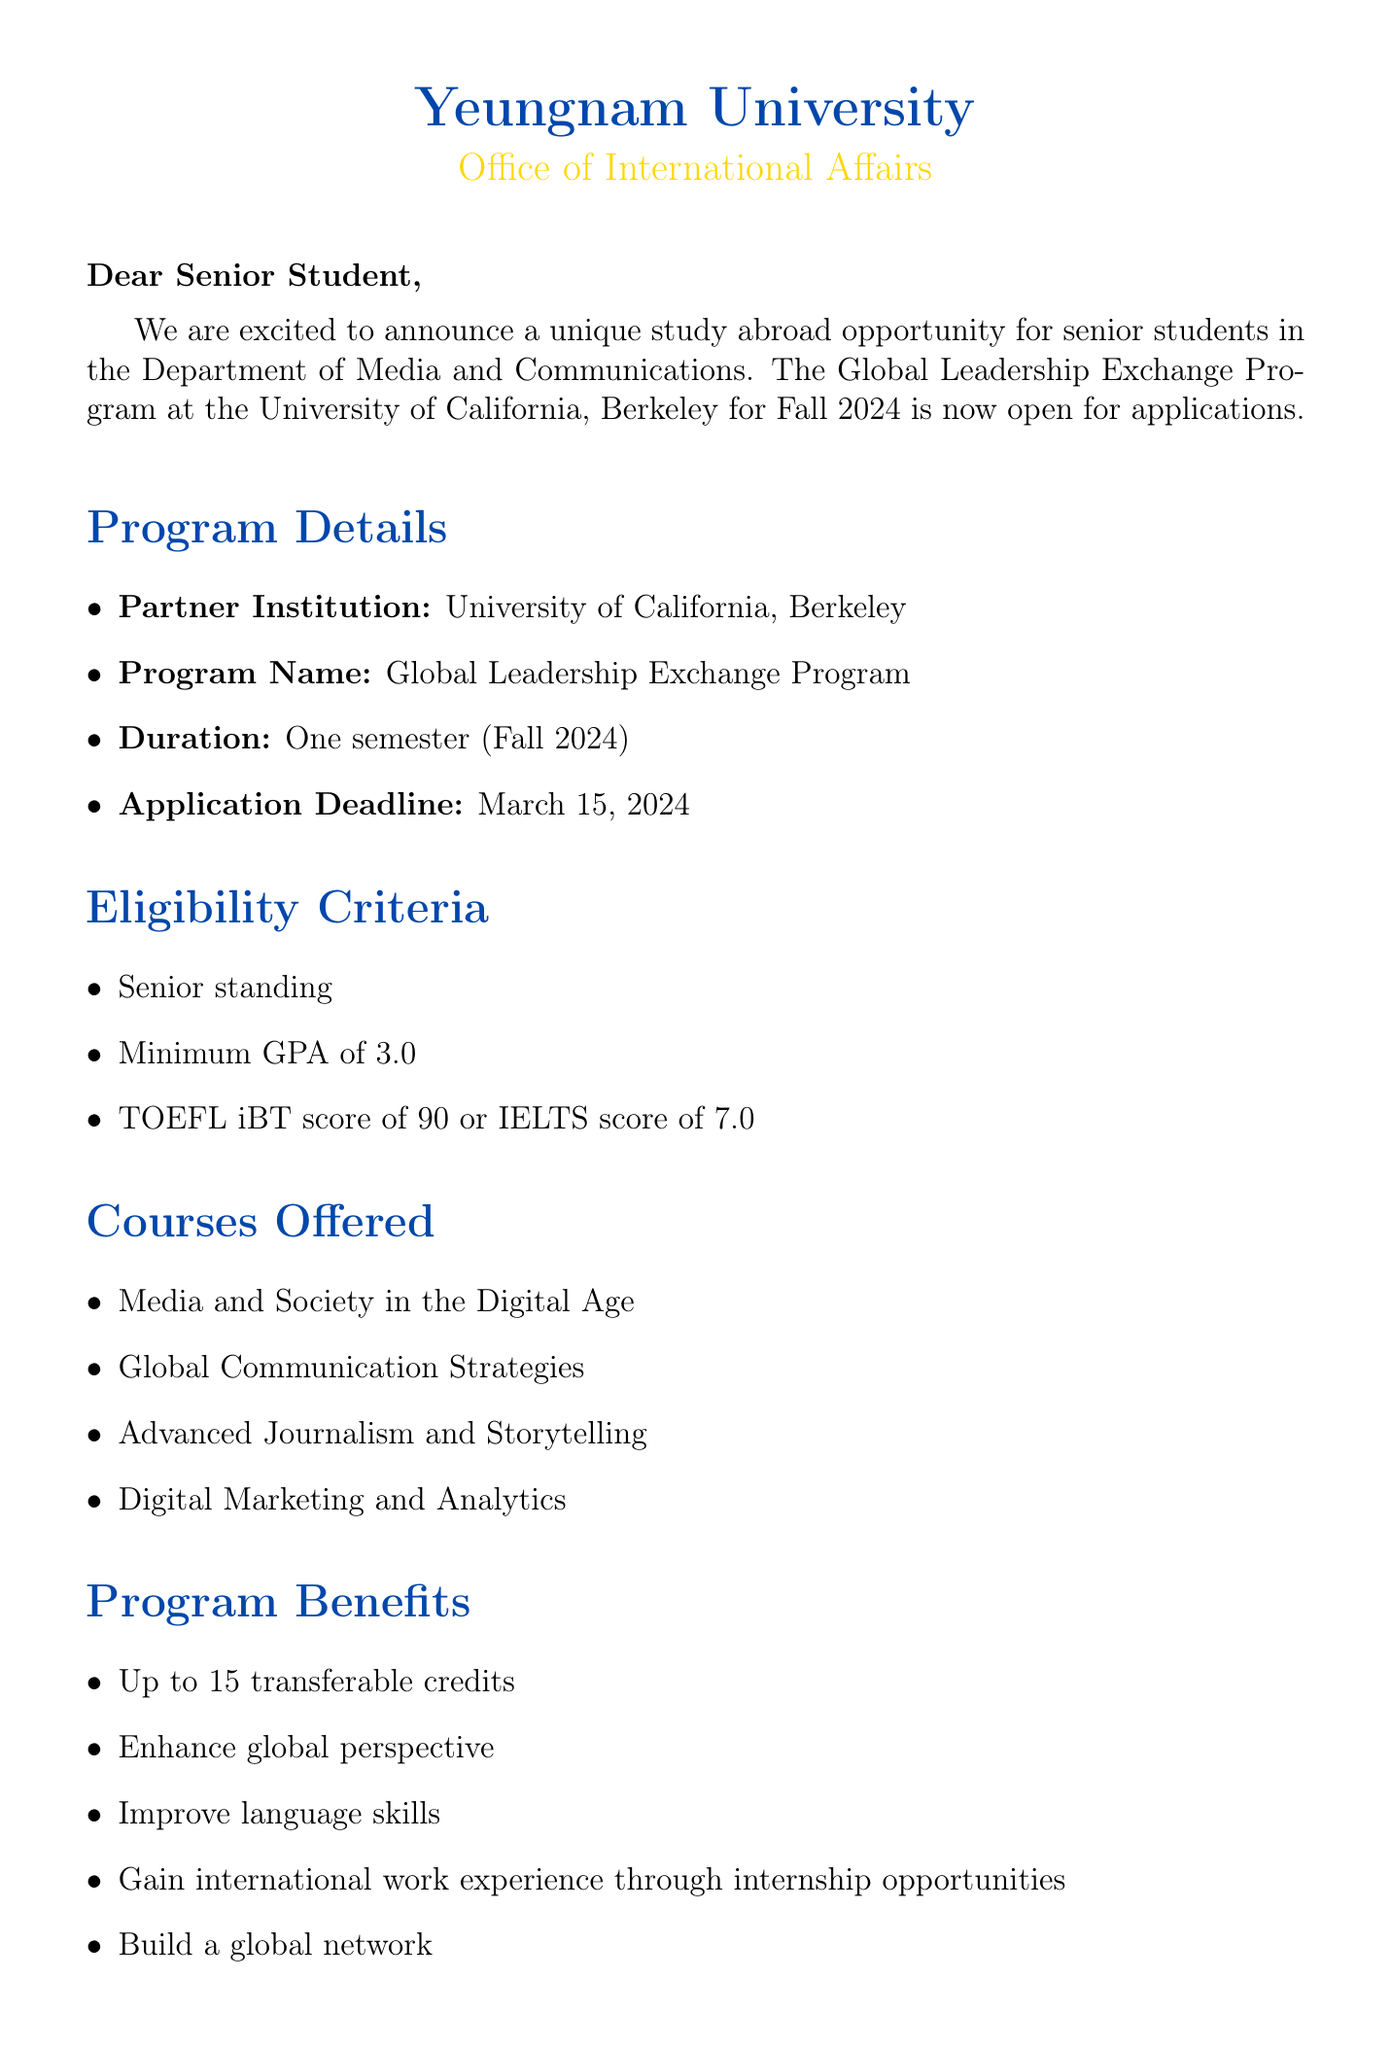What is the name of the partner institution? The partner institution mentioned in the document is the University of California, Berkeley.
Answer: University of California, Berkeley What is the application deadline for the program? The application deadline to apply for the Global Leadership Exchange Program is listed in the document.
Answer: March 15, 2024 What is the minimum GPA requirement for eligibility? The document states that applicants must have a minimum GPA to qualify for the program.
Answer: 3.0 How many credits are transferable from the program? The maximum number of transferable credits is specified in the document under program benefits.
Answer: Up to 15 credits Who is the contact person for the study abroad program? The document provides the name of the individual responsible for coordinating the program.
Answer: Ms. Ji-Eun Park What is one of the estimated costs for housing? The document includes a range for housing costs, specifically for the semester in question.
Answer: $4,500 - $6,000 per semester What is a benefit of participating in this program? The document lists several benefits; one of them is related to enhancing a particular skill.
Answer: Improve language skills When is the information session scheduled? The document specifies a date and time for an information session to inform students about the program.
Answer: February 10, 2024 What is required to complete the application process? The document outlines various steps that need to be taken to apply for the program.
Answer: Submit online application form 